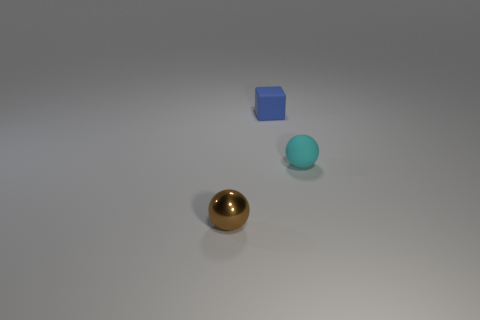Add 2 tiny blue matte blocks. How many objects exist? 5 Subtract all cubes. How many objects are left? 2 Subtract 0 gray balls. How many objects are left? 3 Subtract all big blue matte blocks. Subtract all tiny rubber balls. How many objects are left? 2 Add 2 cyan balls. How many cyan balls are left? 3 Add 1 cyan matte cylinders. How many cyan matte cylinders exist? 1 